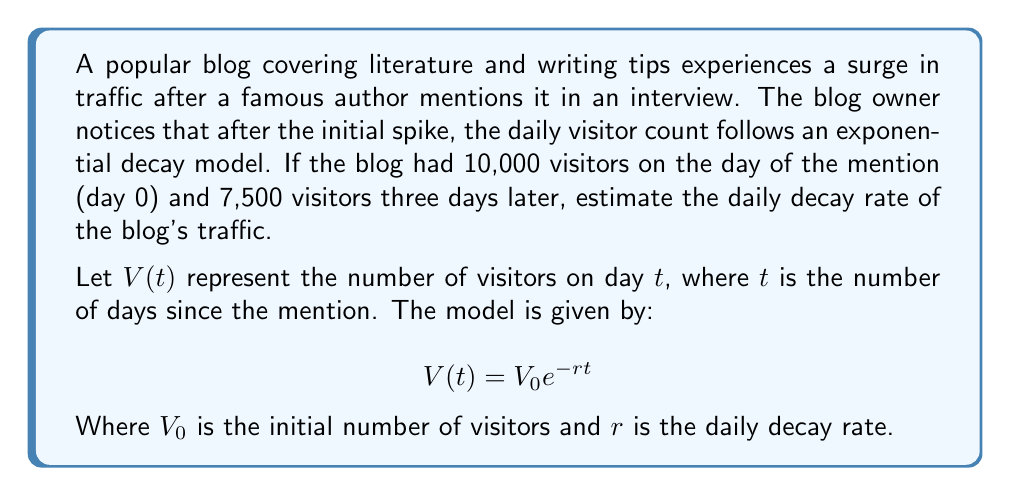Can you solve this math problem? To solve this problem, we'll follow these steps:

1) We know that $V_0 = 10,000$ (initial visitors on day 0)
2) We also know that on day 3, $V(3) = 7,500$

Let's substitute these values into our model equation:

$$7,500 = 10,000 e^{-r(3)}$$

3) Divide both sides by 10,000:

$$0.75 = e^{-3r}$$

4) Take the natural logarithm of both sides:

$$\ln(0.75) = -3r$$

5) Solve for $r$:

$$r = -\frac{\ln(0.75)}{3}$$

6) Calculate the value:

$$r = -\frac{\ln(0.75)}{3} \approx 0.0959$$

7) Convert to a percentage:

$$0.0959 \times 100\% \approx 9.59\%$$

Therefore, the daily decay rate of the blog's traffic is approximately 9.59%.
Answer: $9.59\%$ 